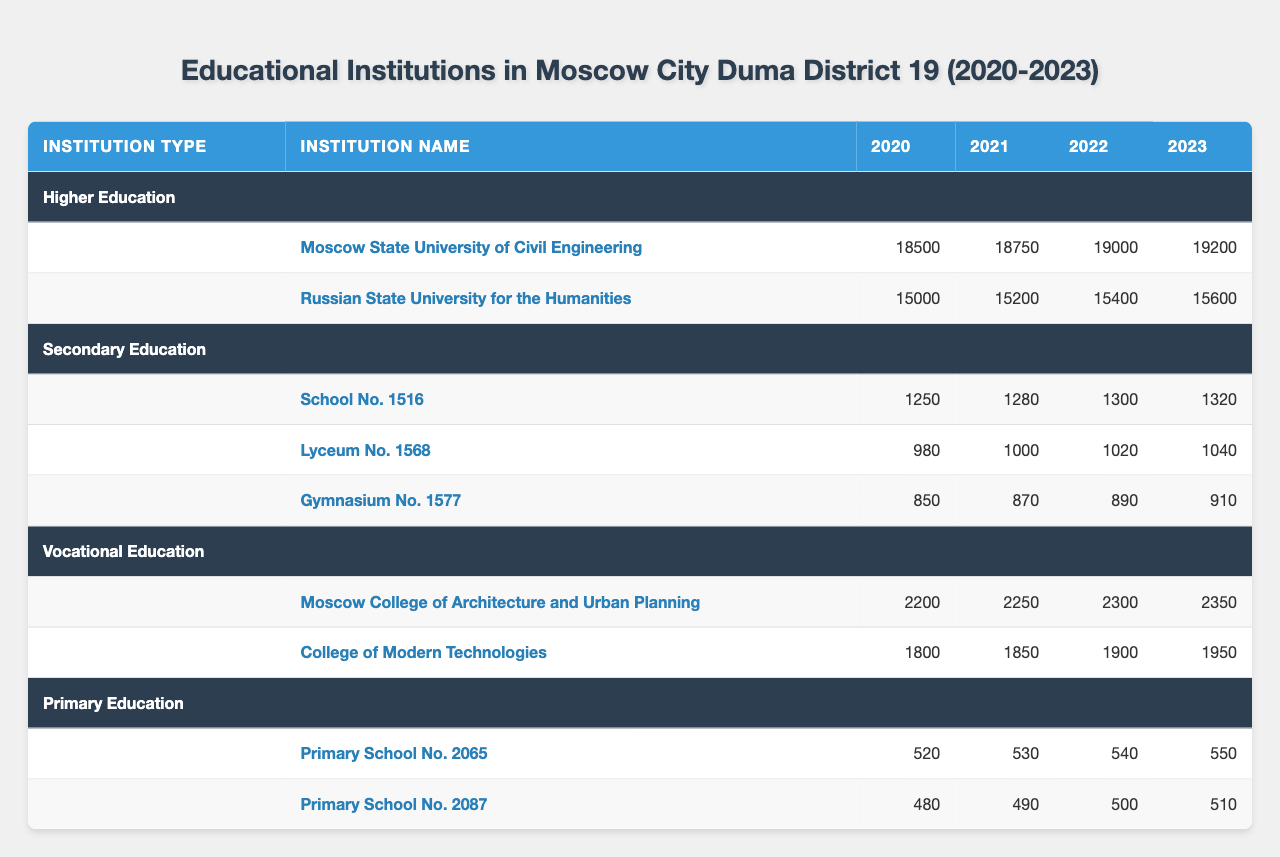What is the total enrollment for higher education institutions in 2023? The two higher education institutions listed are Moscow State University of Civil Engineering (19,200) and Russian State University for the Humanities (15,600). Adding these values gives 19,200 + 15,600 = 34,800.
Answer: 34,800 Which institution had the highest enrollment in 2022? Comparing the enrollment values for all institutions in 2022: Moscow State University of Civil Engineering (19,000), Russian State University for the Humanities (15,400), School No. 1516 (1,300), Lyceum No. 1568 (1,020), Gymnasium No. 1577 (890), Moscow College of Architecture and Urban Planning (2,300), and College of Modern Technologies (1,900), the highest is Moscow State University of Civil Engineering (19,000).
Answer: Moscow State University of Civil Engineering What is the average enrollment for secondary education institutions over the four years? The enrollments for secondary institutions over the years are: School No. 1516 (1,250, 1,280, 1,300, 1,320), Lyceum No. 1568 (980, 1,000, 1,020, 1,040), and Gymnasium No. 1577 (850, 870, 890, 910). The total for each is 1,250 + 1,280 + 1,300 + 1,320 = 5,150; 980 + 1,000 + 1,020 + 1,040 = 4,040; and 850 + 870 + 890 + 910 = 3,520. Summing these gives 5,150 + 4,040 + 3,520 = 12,710. There are 12 enrollment values (4 years across 3 institutions), so the average is 12,710 / 12 = 1,059.17, rounded to 1,059.
Answer: 1,059 Did the enrollment for Primary School No. 2065 increase every year during 2020-2023? The enrollment values for Primary School No. 2065 are: 520 in 2020, 530 in 2021, 540 in 2022, and 550 in 2023. Since each subsequent year shows an increase, the answer is yes.
Answer: Yes What was the total enrollment for vocational education institutions in 2020? The two vocational institutions are Moscow College of Architecture and Urban Planning (2,200) and College of Modern Technologies (1,800). Adding these yields 2,200 + 1,800 = 4,000.
Answer: 4,000 Which type of educational institution experienced the largest increase in total enrollment from 2020 to 2023? For higher education: (19,200 - 18,500) = 700; secondary education: (1,320 - 1,250) = 70; vocational education: (2,350 - 2,200) = 150; primary education: (550 - 520) = 30. The largest increase is from higher education, with an increase of 700.
Answer: Higher education What is the average enrollment for the two institutions in the vocational education category? The total enrollment for both institutions in 2023 is: Moscow College of Architecture and Urban Planning (2,350) and College of Modern Technologies (1,950). This gives a total of 2,350 + 1,950 = 4,300. There are 2 institutions, so the average is 4,300 / 2 = 2,150.
Answer: 2,150 Is the enrollment for Gymnasium No. 1577 consistently below 1,000 from 2020 to 2023? The enrollment numbers for Gymnasium No. 1577 are 850 in 2020, 870 in 2021, 890 in 2022, and 910 in 2023. Since all values are below 1,000, the answer is yes.
Answer: Yes Which institution had the lowest total enrollment across all years? Adding enrollment for all years for each institution, we find Primary School No. 2087 totals 480 + 490 + 500 + 510 = 1,980. Other institutions exceed this total, making this institution the lowest.
Answer: Primary School No. 2087 How much did enrollment increase for College of Modern Technologies from 2020 to 2023? The enrollment for College of Modern Technologies in 2020 was 1,800, and in 2023 it was 1,950. The increase is 1,950 - 1,800 = 150.
Answer: 150 